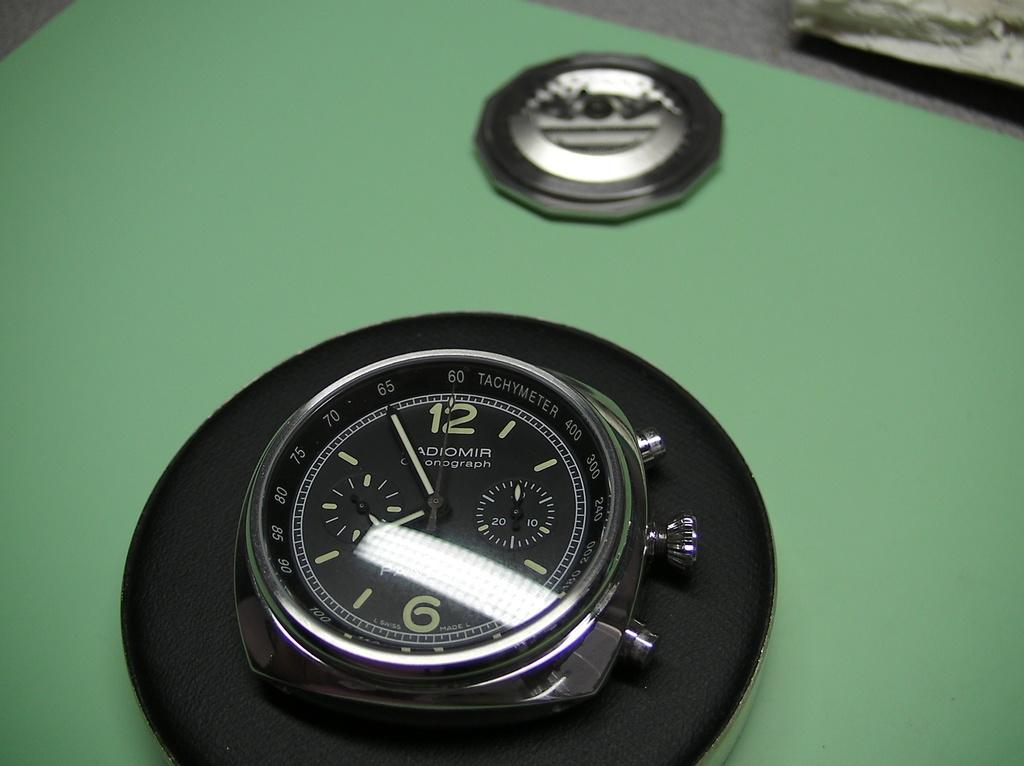<image>
Present a compact description of the photo's key features. A black disk with numbers on it and the word Tachymeter at the  top. 